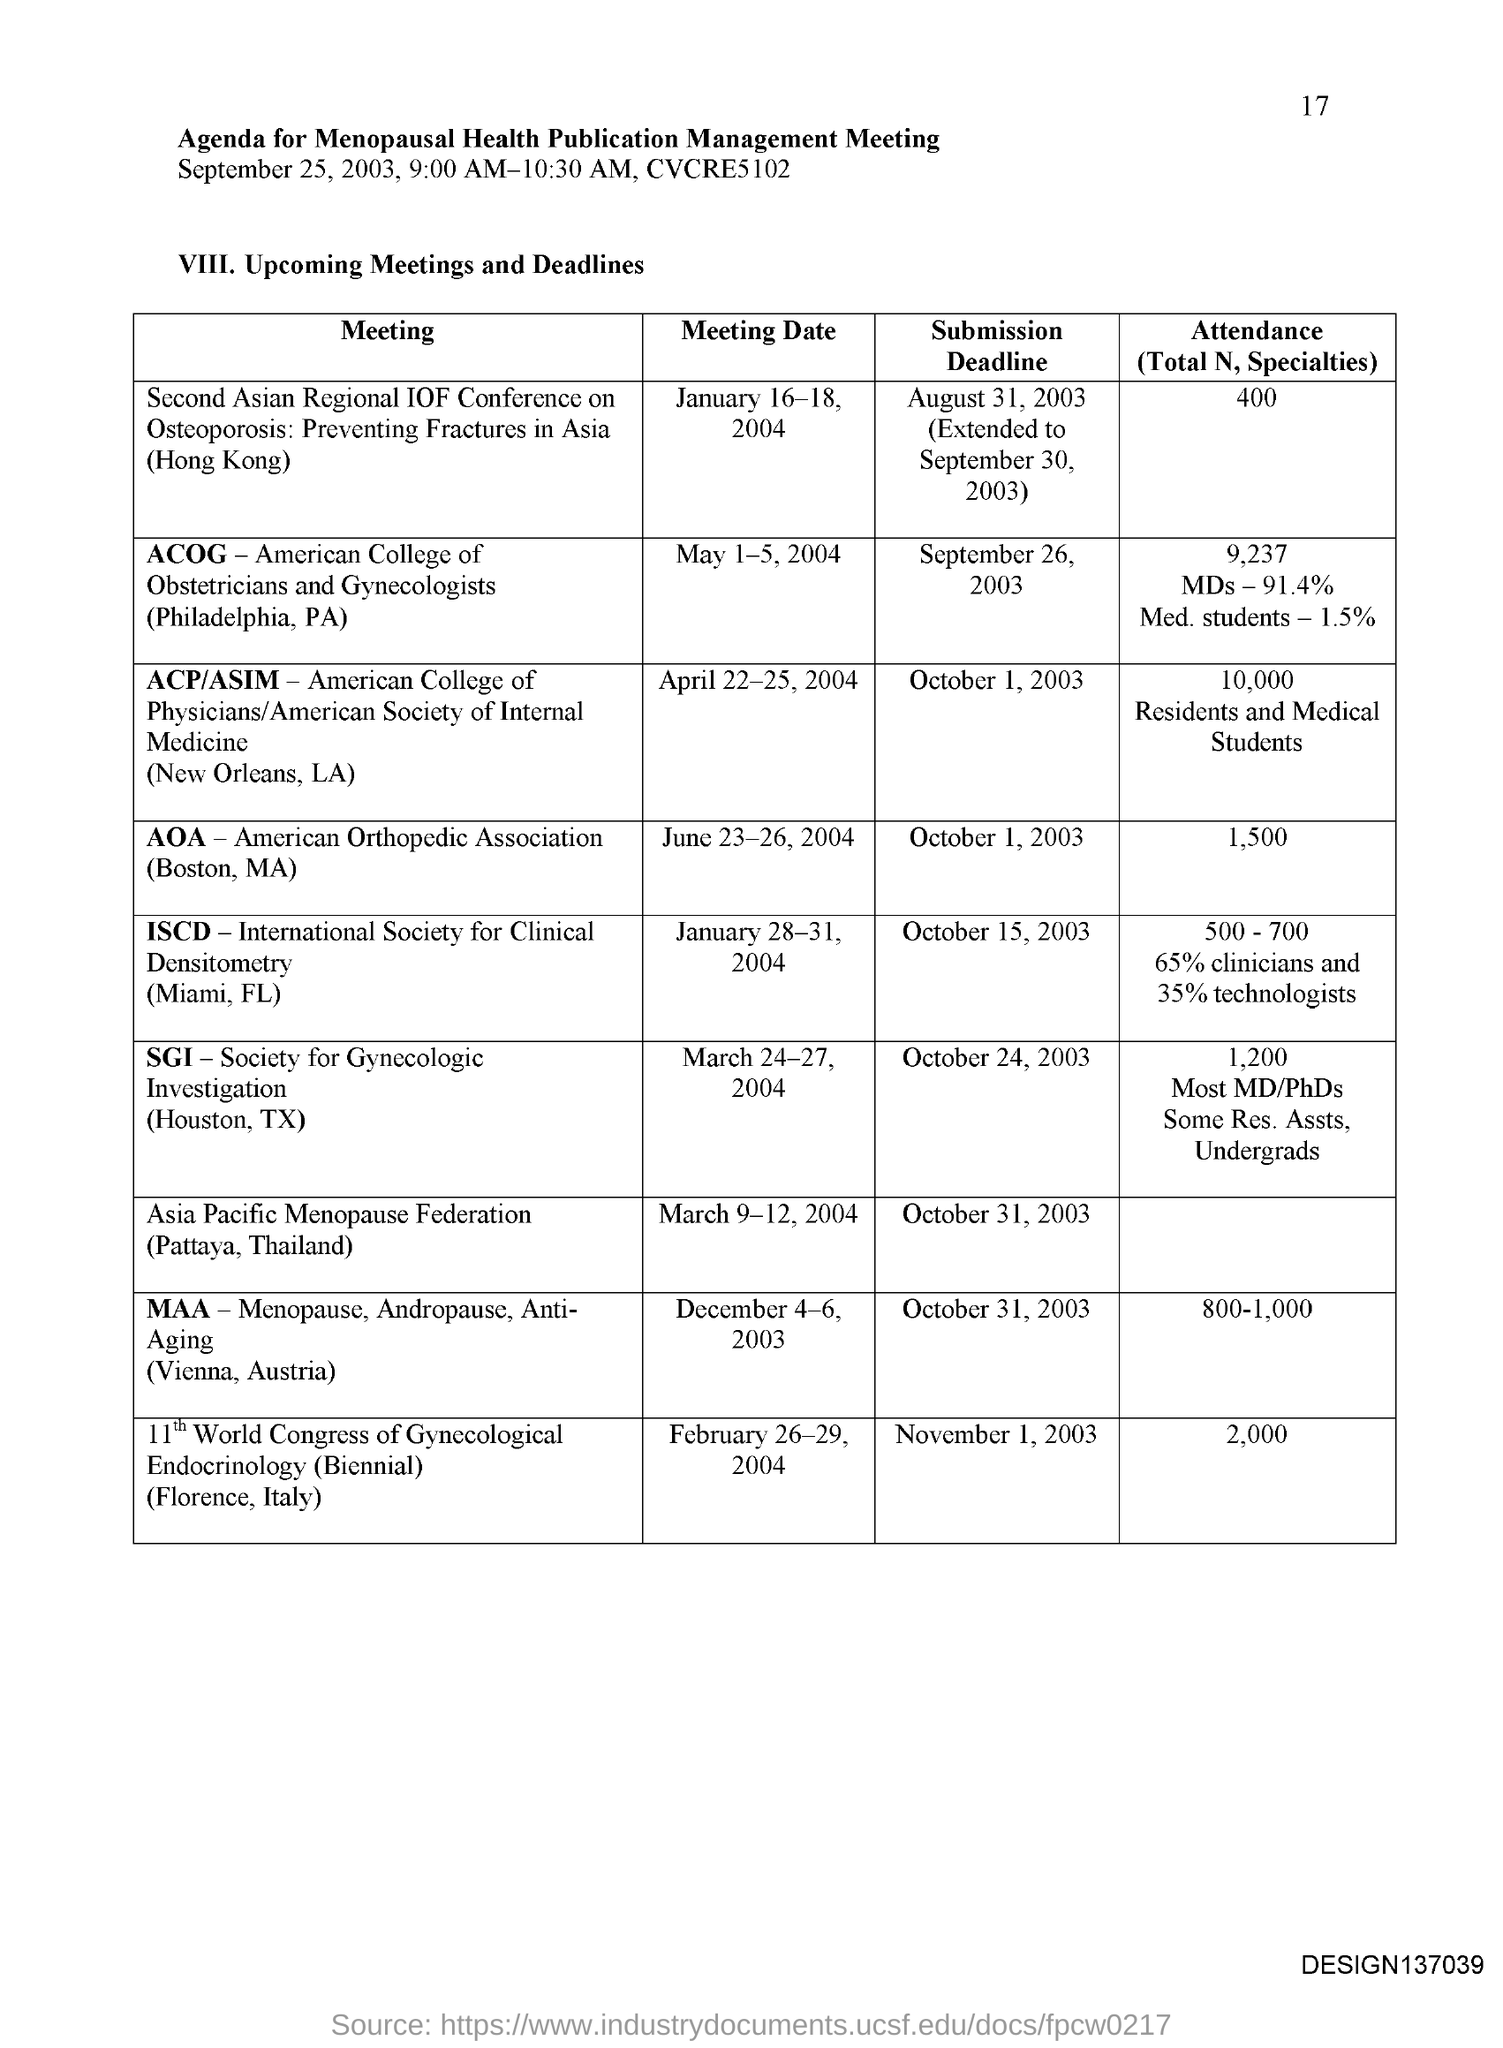What is the Abbreviation for ACOG ?
Offer a terse response. American College of Obstetricians and Gynecologists. What is the date of Submission Deadline for MAA?
Your answer should be very brief. October 31, 2003. What is the Meeting Date for SGI ?
Your answer should be very brief. March 24-27, 2004. What is the Abbreviation for SGI?
Provide a short and direct response. Society for Gynecologic Investigation. What is the Abbreviation for ACP ?
Ensure brevity in your answer.  American College of Physicians. 